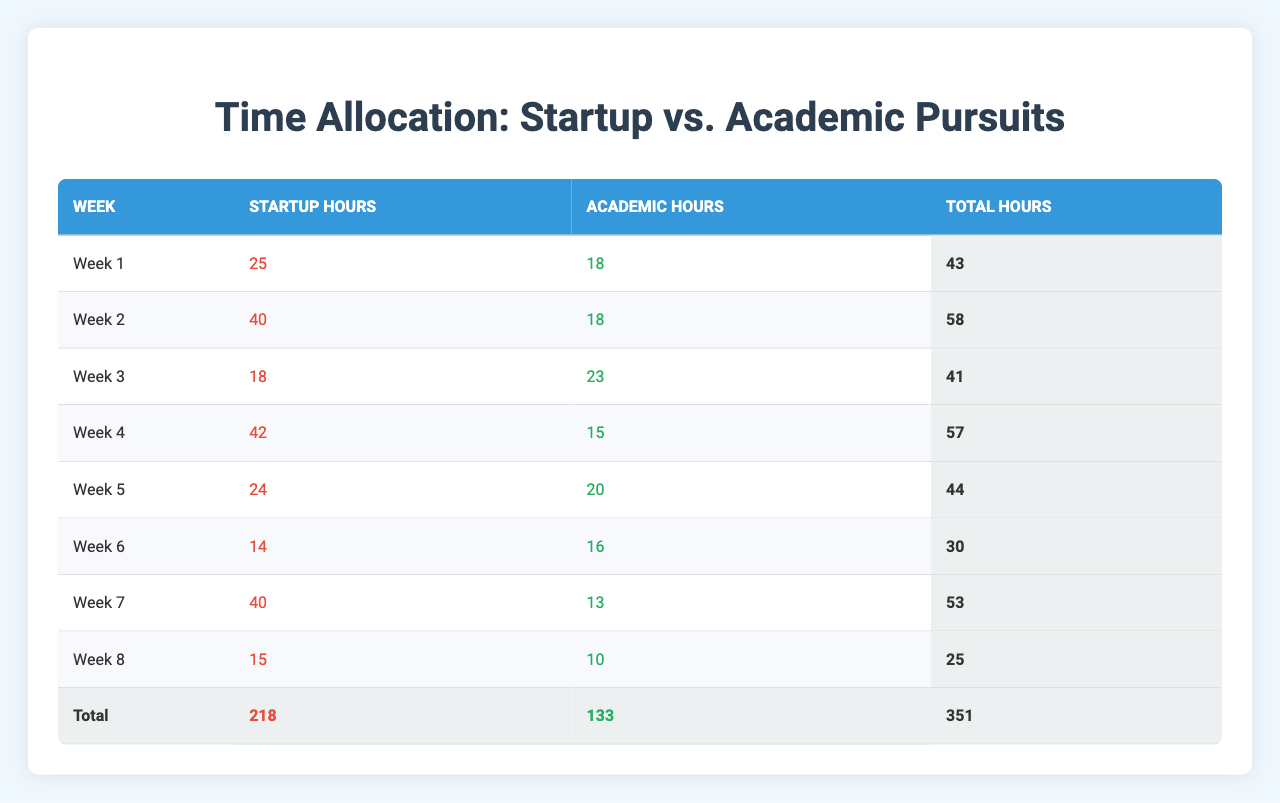What is the total amount of time allocated to startup activities in Week 1? In Week 1, the total startup hours are found in the corresponding row under "Startup Hours," which shows 25 hours.
Answer: 25 How many hours did you study for your academic courses in Week 4? In Week 4, the "Academic Hours" column indicates 15 hours dedicated to studying for academic courses.
Answer: 15 What was the total number of hours spent on both startup activities and academic pursuits in Week 6? In Week 6, the total hours are the sum of "Startup Hours" (14) and "Academic Hours" (16), resulting in a total of 14 + 16 = 30 hours.
Answer: 30 In which week did you spend the most hours on startup activities, and what was that total? By reviewing the "Startup Hours" column, Week 4 shows the highest value of 42 hours dedicated to startup activities.
Answer: Week 4, 42 Is it true that more total hours were allocated to startup activities than academic pursuits over the entire semester? The total hours for startup activities are 218, while academic hours total 133. Since 218 is greater than 133, the statement is true.
Answer: Yes What is the average number of hours spent on academic courses per week, based on the data? To find the average, sum the academic hours for all weeks (18 + 18 + 23 + 15 + 20 + 16 + 13 + 10 = 133). Then divide by the number of weeks (133/8 = 16.625).
Answer: 16.625 Which week had the highest total hours dedicated to both startup and academic activities? The total hours for each week is calculated and compared: Week 2 has the highest total of 58 hours (40 startup + 18 academic). This confirms it had the most total hours.
Answer: Week 2, 58 What was the total time spent on academic studies across all weeks? Adding the academic hours from each week gives 133 hours (18 + 18 + 23 + 15 + 20 + 16 + 13 + 10).
Answer: 133 In which week was the difference between startup hours and academic hours the greatest? Calculate the differences for each week: Week 2 has a difference of 22 hours (40 startup - 18 academic). Comparing all weeks, Week 2 had the greatest difference.
Answer: Week 2, 22 